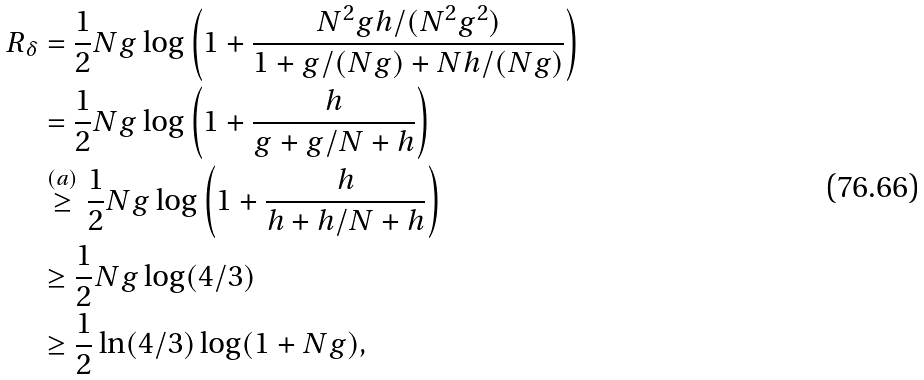<formula> <loc_0><loc_0><loc_500><loc_500>R _ { \delta } & = \frac { 1 } { 2 } N g \log \left ( 1 + \frac { N ^ { 2 } g h / ( N ^ { 2 } g ^ { 2 } ) } { 1 + g / ( N g ) + N h / ( N g ) } \right ) \\ & = \frac { 1 } { 2 } N g \log \left ( 1 + \frac { h } { g + g / N + h } \right ) \\ & \stackrel { ( a ) } { \geq } \frac { 1 } { 2 } N g \log \left ( 1 + \frac { h } { h + h / N + h } \right ) \\ & \geq \frac { 1 } { 2 } N g \log ( 4 / 3 ) \\ & \geq \frac { 1 } { 2 } \ln ( 4 / 3 ) \log ( 1 + N g ) ,</formula> 